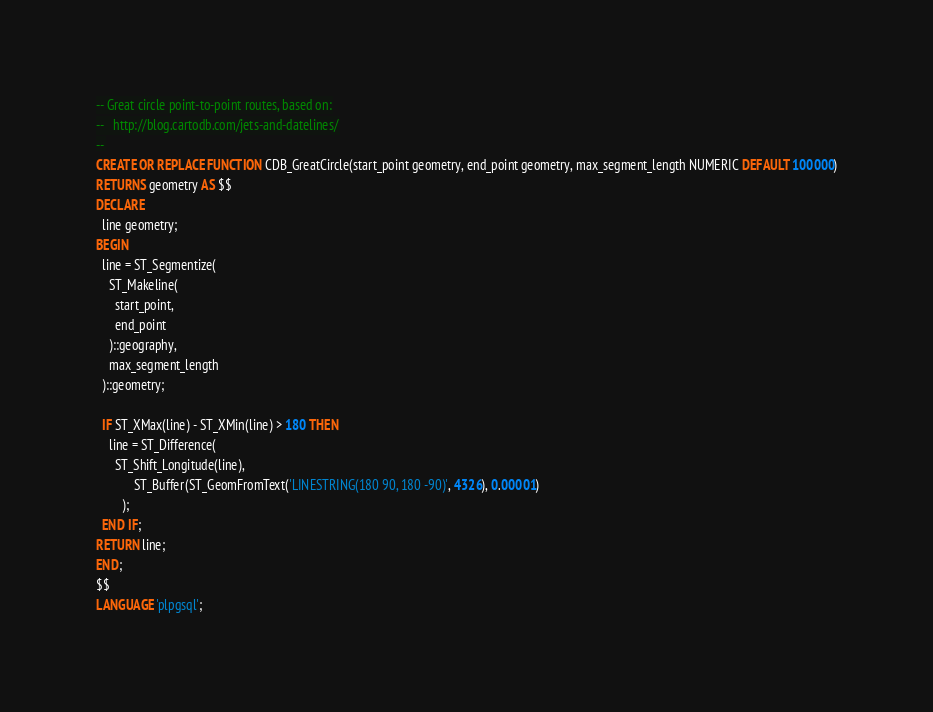<code> <loc_0><loc_0><loc_500><loc_500><_SQL_>-- Great circle point-to-point routes, based on:
--   http://blog.cartodb.com/jets-and-datelines/
--
CREATE OR REPLACE FUNCTION CDB_GreatCircle(start_point geometry, end_point geometry, max_segment_length NUMERIC DEFAULT 100000)
RETURNS geometry AS $$
DECLARE
  line geometry;
BEGIN
  line = ST_Segmentize(
    ST_Makeline(
      start_point,
      end_point
    )::geography,
    max_segment_length
  )::geometry;

  IF ST_XMax(line) - ST_XMin(line) > 180 THEN
    line = ST_Difference(
      ST_Shift_Longitude(line),
			ST_Buffer(ST_GeomFromText('LINESTRING(180 90, 180 -90)', 4326), 0.00001)
		);
  END IF;
RETURN line;
END;
$$
LANGUAGE 'plpgsql';
</code> 